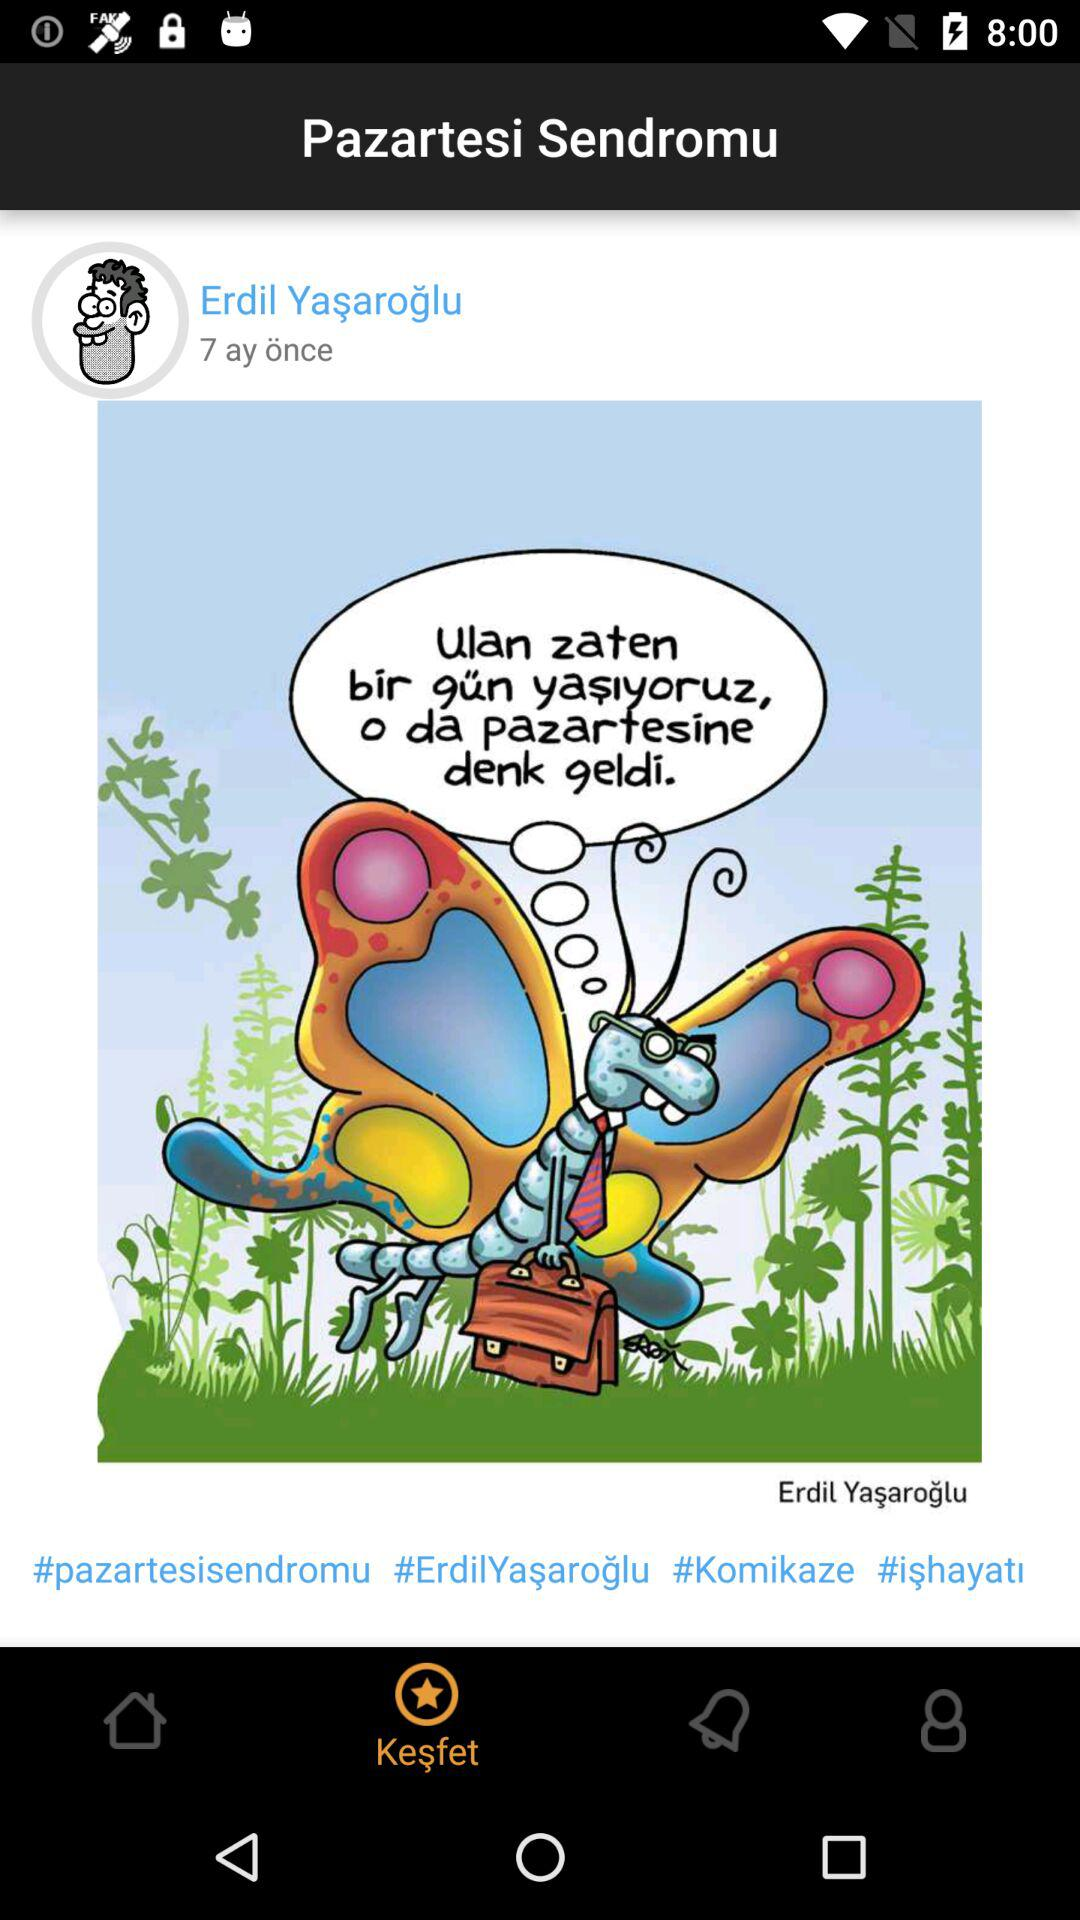How many hashtags are there in this post?
Answer the question using a single word or phrase. 4 